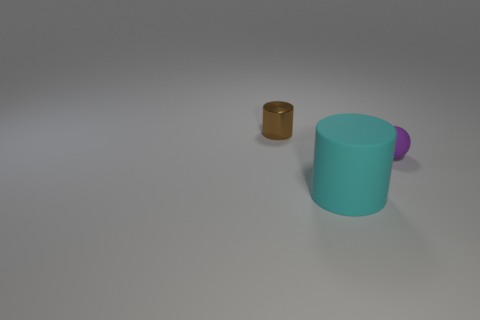Are there any other things that have the same size as the cyan thing?
Your response must be concise. No. How many other objects are there of the same color as the tiny shiny thing?
Your answer should be very brief. 0. There is a shiny thing that is the same size as the purple sphere; what is its shape?
Provide a succinct answer. Cylinder. There is a tiny thing in front of the brown thing; what is its color?
Make the answer very short. Purple. What number of objects are cylinders behind the tiny sphere or tiny things to the left of the tiny rubber thing?
Offer a terse response. 1. Does the shiny thing have the same size as the cyan object?
Offer a terse response. No. How many cylinders are either small purple rubber things or big cyan matte things?
Make the answer very short. 1. What number of objects are both left of the tiny purple matte thing and behind the big cyan cylinder?
Keep it short and to the point. 1. There is a brown thing; is it the same size as the thing that is in front of the purple ball?
Keep it short and to the point. No. There is a tiny thing to the left of the object in front of the rubber sphere; are there any tiny brown cylinders that are on the left side of it?
Keep it short and to the point. No. 